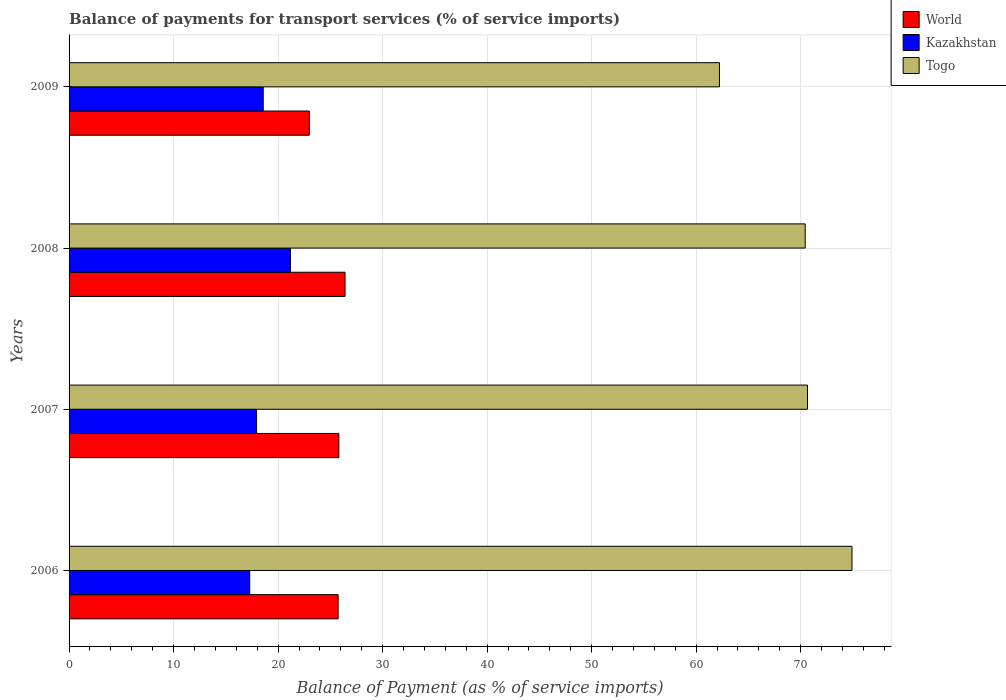How many different coloured bars are there?
Make the answer very short. 3. How many bars are there on the 1st tick from the top?
Provide a short and direct response. 3. How many bars are there on the 3rd tick from the bottom?
Offer a terse response. 3. What is the label of the 1st group of bars from the top?
Offer a terse response. 2009. In how many cases, is the number of bars for a given year not equal to the number of legend labels?
Your answer should be compact. 0. What is the balance of payments for transport services in World in 2009?
Provide a short and direct response. 22.99. Across all years, what is the maximum balance of payments for transport services in Togo?
Offer a very short reply. 74.91. Across all years, what is the minimum balance of payments for transport services in Kazakhstan?
Offer a very short reply. 17.28. In which year was the balance of payments for transport services in Togo minimum?
Make the answer very short. 2009. What is the total balance of payments for transport services in Togo in the graph?
Offer a terse response. 278.22. What is the difference between the balance of payments for transport services in Kazakhstan in 2007 and that in 2009?
Make the answer very short. -0.64. What is the difference between the balance of payments for transport services in Togo in 2009 and the balance of payments for transport services in World in 2007?
Provide a succinct answer. 36.42. What is the average balance of payments for transport services in World per year?
Offer a very short reply. 25.24. In the year 2009, what is the difference between the balance of payments for transport services in World and balance of payments for transport services in Kazakhstan?
Offer a terse response. 4.41. In how many years, is the balance of payments for transport services in Togo greater than 66 %?
Make the answer very short. 3. What is the ratio of the balance of payments for transport services in Kazakhstan in 2007 to that in 2008?
Provide a short and direct response. 0.85. Is the difference between the balance of payments for transport services in World in 2006 and 2007 greater than the difference between the balance of payments for transport services in Kazakhstan in 2006 and 2007?
Your answer should be compact. Yes. What is the difference between the highest and the second highest balance of payments for transport services in World?
Provide a succinct answer. 0.59. What is the difference between the highest and the lowest balance of payments for transport services in World?
Ensure brevity in your answer.  3.42. What does the 1st bar from the top in 2006 represents?
Offer a terse response. Togo. What does the 1st bar from the bottom in 2008 represents?
Your answer should be compact. World. What is the difference between two consecutive major ticks on the X-axis?
Keep it short and to the point. 10. Are the values on the major ticks of X-axis written in scientific E-notation?
Make the answer very short. No. Does the graph contain any zero values?
Your response must be concise. No. Does the graph contain grids?
Your answer should be compact. Yes. Where does the legend appear in the graph?
Make the answer very short. Top right. How are the legend labels stacked?
Provide a succinct answer. Vertical. What is the title of the graph?
Your answer should be compact. Balance of payments for transport services (% of service imports). What is the label or title of the X-axis?
Give a very brief answer. Balance of Payment (as % of service imports). What is the label or title of the Y-axis?
Offer a terse response. Years. What is the Balance of Payment (as % of service imports) in World in 2006?
Provide a succinct answer. 25.74. What is the Balance of Payment (as % of service imports) of Kazakhstan in 2006?
Provide a short and direct response. 17.28. What is the Balance of Payment (as % of service imports) in Togo in 2006?
Keep it short and to the point. 74.91. What is the Balance of Payment (as % of service imports) in World in 2007?
Make the answer very short. 25.81. What is the Balance of Payment (as % of service imports) of Kazakhstan in 2007?
Provide a succinct answer. 17.94. What is the Balance of Payment (as % of service imports) of Togo in 2007?
Provide a succinct answer. 70.65. What is the Balance of Payment (as % of service imports) in World in 2008?
Provide a succinct answer. 26.4. What is the Balance of Payment (as % of service imports) of Kazakhstan in 2008?
Provide a short and direct response. 21.18. What is the Balance of Payment (as % of service imports) in Togo in 2008?
Your answer should be compact. 70.43. What is the Balance of Payment (as % of service imports) in World in 2009?
Your answer should be compact. 22.99. What is the Balance of Payment (as % of service imports) in Kazakhstan in 2009?
Keep it short and to the point. 18.58. What is the Balance of Payment (as % of service imports) in Togo in 2009?
Provide a succinct answer. 62.23. Across all years, what is the maximum Balance of Payment (as % of service imports) in World?
Provide a short and direct response. 26.4. Across all years, what is the maximum Balance of Payment (as % of service imports) of Kazakhstan?
Provide a short and direct response. 21.18. Across all years, what is the maximum Balance of Payment (as % of service imports) in Togo?
Offer a very short reply. 74.91. Across all years, what is the minimum Balance of Payment (as % of service imports) of World?
Your answer should be compact. 22.99. Across all years, what is the minimum Balance of Payment (as % of service imports) of Kazakhstan?
Provide a short and direct response. 17.28. Across all years, what is the minimum Balance of Payment (as % of service imports) in Togo?
Offer a very short reply. 62.23. What is the total Balance of Payment (as % of service imports) in World in the graph?
Provide a short and direct response. 100.95. What is the total Balance of Payment (as % of service imports) in Kazakhstan in the graph?
Give a very brief answer. 74.98. What is the total Balance of Payment (as % of service imports) in Togo in the graph?
Make the answer very short. 278.22. What is the difference between the Balance of Payment (as % of service imports) in World in 2006 and that in 2007?
Your answer should be compact. -0.07. What is the difference between the Balance of Payment (as % of service imports) of Kazakhstan in 2006 and that in 2007?
Offer a terse response. -0.66. What is the difference between the Balance of Payment (as % of service imports) in Togo in 2006 and that in 2007?
Provide a succinct answer. 4.26. What is the difference between the Balance of Payment (as % of service imports) in World in 2006 and that in 2008?
Make the answer very short. -0.66. What is the difference between the Balance of Payment (as % of service imports) in Kazakhstan in 2006 and that in 2008?
Offer a very short reply. -3.9. What is the difference between the Balance of Payment (as % of service imports) in Togo in 2006 and that in 2008?
Make the answer very short. 4.48. What is the difference between the Balance of Payment (as % of service imports) in World in 2006 and that in 2009?
Provide a short and direct response. 2.76. What is the difference between the Balance of Payment (as % of service imports) in Kazakhstan in 2006 and that in 2009?
Your response must be concise. -1.29. What is the difference between the Balance of Payment (as % of service imports) in Togo in 2006 and that in 2009?
Keep it short and to the point. 12.68. What is the difference between the Balance of Payment (as % of service imports) in World in 2007 and that in 2008?
Provide a succinct answer. -0.59. What is the difference between the Balance of Payment (as % of service imports) of Kazakhstan in 2007 and that in 2008?
Make the answer very short. -3.24. What is the difference between the Balance of Payment (as % of service imports) in Togo in 2007 and that in 2008?
Your answer should be compact. 0.22. What is the difference between the Balance of Payment (as % of service imports) in World in 2007 and that in 2009?
Offer a terse response. 2.83. What is the difference between the Balance of Payment (as % of service imports) of Kazakhstan in 2007 and that in 2009?
Keep it short and to the point. -0.64. What is the difference between the Balance of Payment (as % of service imports) in Togo in 2007 and that in 2009?
Keep it short and to the point. 8.42. What is the difference between the Balance of Payment (as % of service imports) in World in 2008 and that in 2009?
Offer a very short reply. 3.42. What is the difference between the Balance of Payment (as % of service imports) of Kazakhstan in 2008 and that in 2009?
Provide a short and direct response. 2.61. What is the difference between the Balance of Payment (as % of service imports) of Togo in 2008 and that in 2009?
Ensure brevity in your answer.  8.2. What is the difference between the Balance of Payment (as % of service imports) in World in 2006 and the Balance of Payment (as % of service imports) in Kazakhstan in 2007?
Provide a succinct answer. 7.81. What is the difference between the Balance of Payment (as % of service imports) of World in 2006 and the Balance of Payment (as % of service imports) of Togo in 2007?
Keep it short and to the point. -44.91. What is the difference between the Balance of Payment (as % of service imports) in Kazakhstan in 2006 and the Balance of Payment (as % of service imports) in Togo in 2007?
Give a very brief answer. -53.37. What is the difference between the Balance of Payment (as % of service imports) of World in 2006 and the Balance of Payment (as % of service imports) of Kazakhstan in 2008?
Offer a very short reply. 4.56. What is the difference between the Balance of Payment (as % of service imports) of World in 2006 and the Balance of Payment (as % of service imports) of Togo in 2008?
Offer a terse response. -44.69. What is the difference between the Balance of Payment (as % of service imports) of Kazakhstan in 2006 and the Balance of Payment (as % of service imports) of Togo in 2008?
Give a very brief answer. -53.15. What is the difference between the Balance of Payment (as % of service imports) of World in 2006 and the Balance of Payment (as % of service imports) of Kazakhstan in 2009?
Your response must be concise. 7.17. What is the difference between the Balance of Payment (as % of service imports) in World in 2006 and the Balance of Payment (as % of service imports) in Togo in 2009?
Give a very brief answer. -36.49. What is the difference between the Balance of Payment (as % of service imports) in Kazakhstan in 2006 and the Balance of Payment (as % of service imports) in Togo in 2009?
Your response must be concise. -44.95. What is the difference between the Balance of Payment (as % of service imports) in World in 2007 and the Balance of Payment (as % of service imports) in Kazakhstan in 2008?
Your answer should be very brief. 4.63. What is the difference between the Balance of Payment (as % of service imports) of World in 2007 and the Balance of Payment (as % of service imports) of Togo in 2008?
Make the answer very short. -44.62. What is the difference between the Balance of Payment (as % of service imports) in Kazakhstan in 2007 and the Balance of Payment (as % of service imports) in Togo in 2008?
Offer a terse response. -52.49. What is the difference between the Balance of Payment (as % of service imports) of World in 2007 and the Balance of Payment (as % of service imports) of Kazakhstan in 2009?
Offer a very short reply. 7.24. What is the difference between the Balance of Payment (as % of service imports) of World in 2007 and the Balance of Payment (as % of service imports) of Togo in 2009?
Your answer should be very brief. -36.42. What is the difference between the Balance of Payment (as % of service imports) of Kazakhstan in 2007 and the Balance of Payment (as % of service imports) of Togo in 2009?
Make the answer very short. -44.29. What is the difference between the Balance of Payment (as % of service imports) of World in 2008 and the Balance of Payment (as % of service imports) of Kazakhstan in 2009?
Your response must be concise. 7.83. What is the difference between the Balance of Payment (as % of service imports) of World in 2008 and the Balance of Payment (as % of service imports) of Togo in 2009?
Your answer should be very brief. -35.83. What is the difference between the Balance of Payment (as % of service imports) in Kazakhstan in 2008 and the Balance of Payment (as % of service imports) in Togo in 2009?
Make the answer very short. -41.05. What is the average Balance of Payment (as % of service imports) in World per year?
Your response must be concise. 25.24. What is the average Balance of Payment (as % of service imports) of Kazakhstan per year?
Provide a short and direct response. 18.74. What is the average Balance of Payment (as % of service imports) of Togo per year?
Provide a succinct answer. 69.56. In the year 2006, what is the difference between the Balance of Payment (as % of service imports) of World and Balance of Payment (as % of service imports) of Kazakhstan?
Give a very brief answer. 8.46. In the year 2006, what is the difference between the Balance of Payment (as % of service imports) of World and Balance of Payment (as % of service imports) of Togo?
Provide a short and direct response. -49.17. In the year 2006, what is the difference between the Balance of Payment (as % of service imports) in Kazakhstan and Balance of Payment (as % of service imports) in Togo?
Offer a terse response. -57.63. In the year 2007, what is the difference between the Balance of Payment (as % of service imports) in World and Balance of Payment (as % of service imports) in Kazakhstan?
Provide a succinct answer. 7.87. In the year 2007, what is the difference between the Balance of Payment (as % of service imports) in World and Balance of Payment (as % of service imports) in Togo?
Offer a very short reply. -44.84. In the year 2007, what is the difference between the Balance of Payment (as % of service imports) of Kazakhstan and Balance of Payment (as % of service imports) of Togo?
Ensure brevity in your answer.  -52.71. In the year 2008, what is the difference between the Balance of Payment (as % of service imports) of World and Balance of Payment (as % of service imports) of Kazakhstan?
Give a very brief answer. 5.22. In the year 2008, what is the difference between the Balance of Payment (as % of service imports) of World and Balance of Payment (as % of service imports) of Togo?
Your answer should be very brief. -44.03. In the year 2008, what is the difference between the Balance of Payment (as % of service imports) of Kazakhstan and Balance of Payment (as % of service imports) of Togo?
Ensure brevity in your answer.  -49.25. In the year 2009, what is the difference between the Balance of Payment (as % of service imports) in World and Balance of Payment (as % of service imports) in Kazakhstan?
Your answer should be very brief. 4.41. In the year 2009, what is the difference between the Balance of Payment (as % of service imports) in World and Balance of Payment (as % of service imports) in Togo?
Your answer should be compact. -39.24. In the year 2009, what is the difference between the Balance of Payment (as % of service imports) of Kazakhstan and Balance of Payment (as % of service imports) of Togo?
Your answer should be very brief. -43.65. What is the ratio of the Balance of Payment (as % of service imports) in Kazakhstan in 2006 to that in 2007?
Make the answer very short. 0.96. What is the ratio of the Balance of Payment (as % of service imports) in Togo in 2006 to that in 2007?
Provide a succinct answer. 1.06. What is the ratio of the Balance of Payment (as % of service imports) of World in 2006 to that in 2008?
Provide a succinct answer. 0.97. What is the ratio of the Balance of Payment (as % of service imports) in Kazakhstan in 2006 to that in 2008?
Provide a succinct answer. 0.82. What is the ratio of the Balance of Payment (as % of service imports) in Togo in 2006 to that in 2008?
Provide a short and direct response. 1.06. What is the ratio of the Balance of Payment (as % of service imports) of World in 2006 to that in 2009?
Offer a terse response. 1.12. What is the ratio of the Balance of Payment (as % of service imports) in Kazakhstan in 2006 to that in 2009?
Give a very brief answer. 0.93. What is the ratio of the Balance of Payment (as % of service imports) of Togo in 2006 to that in 2009?
Your answer should be compact. 1.2. What is the ratio of the Balance of Payment (as % of service imports) in World in 2007 to that in 2008?
Keep it short and to the point. 0.98. What is the ratio of the Balance of Payment (as % of service imports) in Kazakhstan in 2007 to that in 2008?
Your response must be concise. 0.85. What is the ratio of the Balance of Payment (as % of service imports) of World in 2007 to that in 2009?
Your answer should be very brief. 1.12. What is the ratio of the Balance of Payment (as % of service imports) of Kazakhstan in 2007 to that in 2009?
Your answer should be very brief. 0.97. What is the ratio of the Balance of Payment (as % of service imports) in Togo in 2007 to that in 2009?
Make the answer very short. 1.14. What is the ratio of the Balance of Payment (as % of service imports) in World in 2008 to that in 2009?
Offer a terse response. 1.15. What is the ratio of the Balance of Payment (as % of service imports) in Kazakhstan in 2008 to that in 2009?
Offer a terse response. 1.14. What is the ratio of the Balance of Payment (as % of service imports) of Togo in 2008 to that in 2009?
Your response must be concise. 1.13. What is the difference between the highest and the second highest Balance of Payment (as % of service imports) of World?
Offer a terse response. 0.59. What is the difference between the highest and the second highest Balance of Payment (as % of service imports) of Kazakhstan?
Make the answer very short. 2.61. What is the difference between the highest and the second highest Balance of Payment (as % of service imports) in Togo?
Offer a terse response. 4.26. What is the difference between the highest and the lowest Balance of Payment (as % of service imports) of World?
Your answer should be compact. 3.42. What is the difference between the highest and the lowest Balance of Payment (as % of service imports) in Kazakhstan?
Your answer should be very brief. 3.9. What is the difference between the highest and the lowest Balance of Payment (as % of service imports) in Togo?
Give a very brief answer. 12.68. 